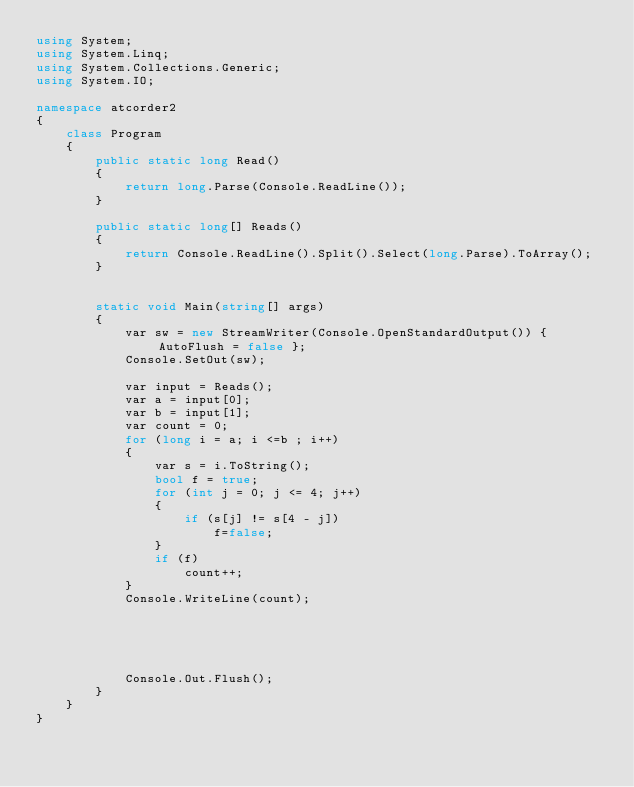<code> <loc_0><loc_0><loc_500><loc_500><_C#_>using System;
using System.Linq;
using System.Collections.Generic;
using System.IO;

namespace atcorder2
{
    class Program
    {
        public static long Read()
        {
            return long.Parse(Console.ReadLine());
        }

        public static long[] Reads()
        {
            return Console.ReadLine().Split().Select(long.Parse).ToArray();
        }


        static void Main(string[] args)
        {
            var sw = new StreamWriter(Console.OpenStandardOutput()) { AutoFlush = false };
            Console.SetOut(sw);

            var input = Reads();
            var a = input[0];
            var b = input[1];
            var count = 0;
            for (long i = a; i <=b ; i++)
            {
                var s = i.ToString();
                bool f = true;
                for (int j = 0; j <= 4; j++)
                {
                    if (s[j] != s[4 - j])
                        f=false;
                }
                if (f)
                    count++;
            }
            Console.WriteLine(count);





            Console.Out.Flush();
        }
    }
}</code> 